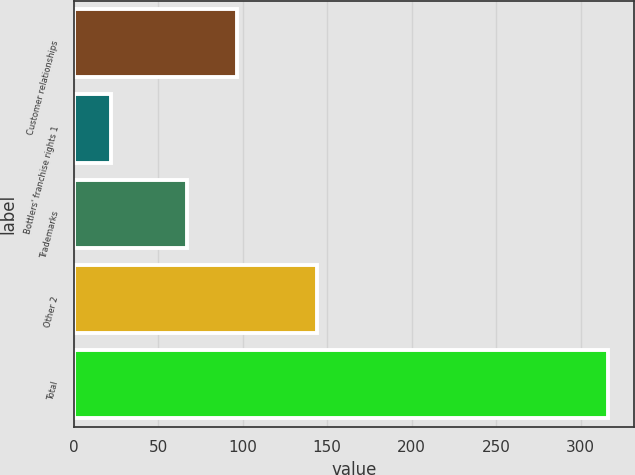<chart> <loc_0><loc_0><loc_500><loc_500><bar_chart><fcel>Customer relationships<fcel>Bottlers' franchise rights 1<fcel>Trademarks<fcel>Other 2<fcel>Total<nl><fcel>96.4<fcel>22<fcel>67<fcel>144<fcel>316<nl></chart> 